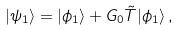<formula> <loc_0><loc_0><loc_500><loc_500>| \psi _ { 1 } \rangle = | \phi _ { 1 } \rangle + G _ { 0 } \tilde { T } | \phi _ { 1 } \rangle \, ,</formula> 